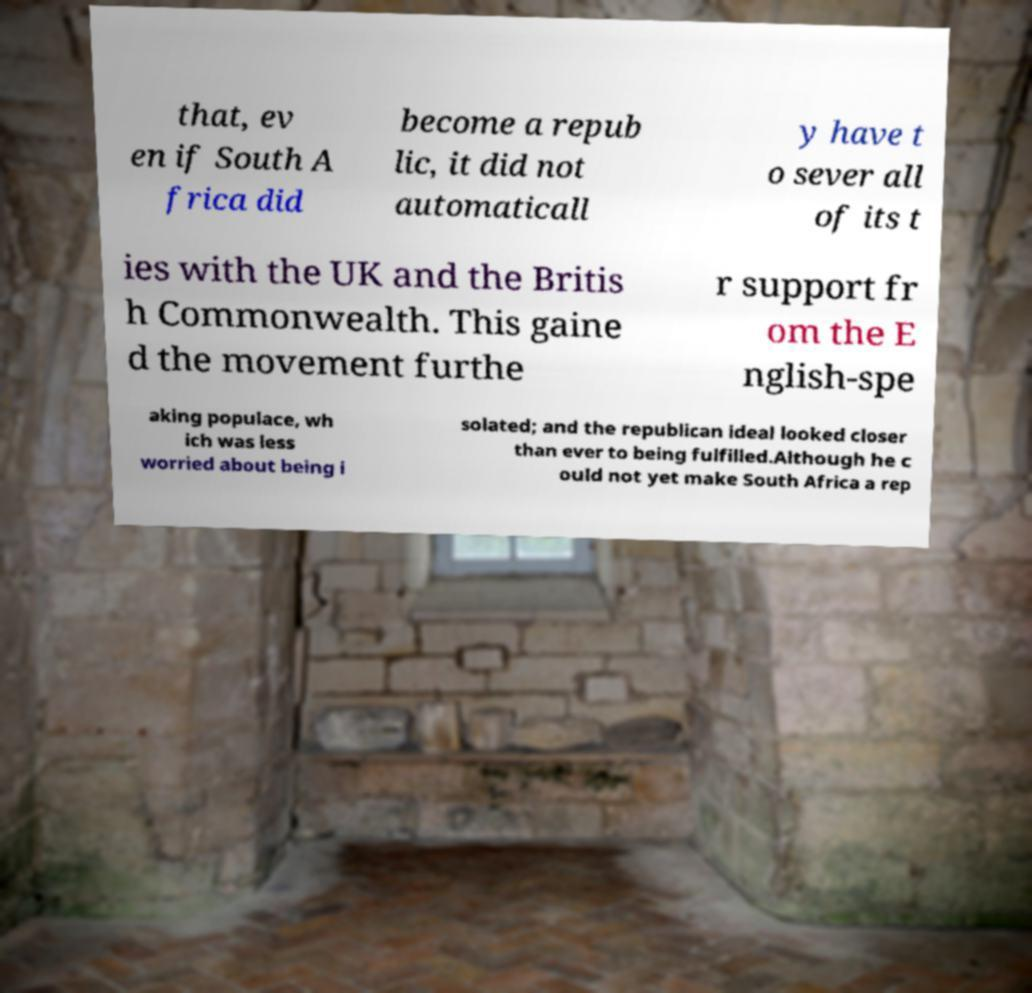For documentation purposes, I need the text within this image transcribed. Could you provide that? that, ev en if South A frica did become a repub lic, it did not automaticall y have t o sever all of its t ies with the UK and the Britis h Commonwealth. This gaine d the movement furthe r support fr om the E nglish-spe aking populace, wh ich was less worried about being i solated; and the republican ideal looked closer than ever to being fulfilled.Although he c ould not yet make South Africa a rep 